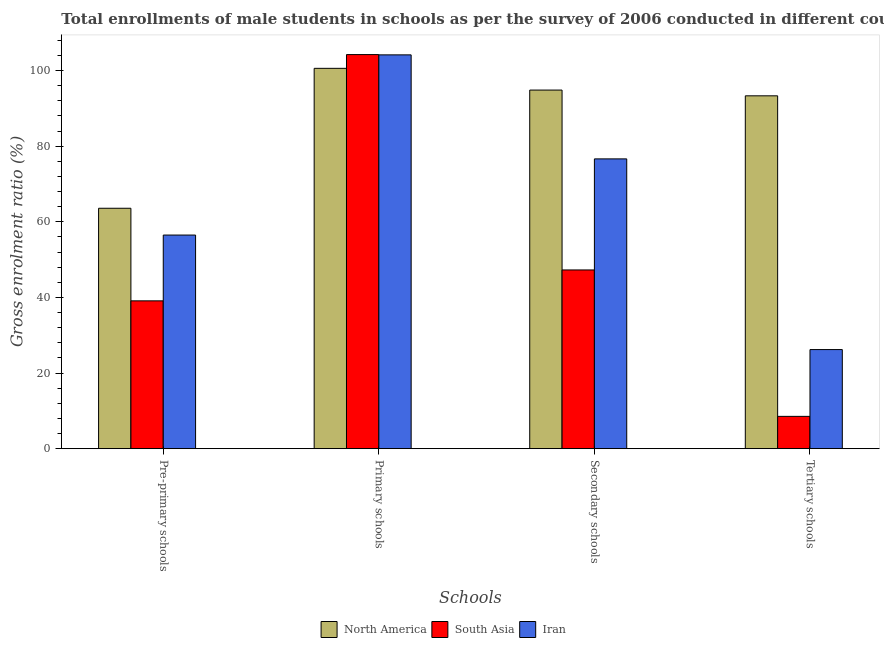How many different coloured bars are there?
Give a very brief answer. 3. How many bars are there on the 4th tick from the left?
Your answer should be compact. 3. How many bars are there on the 3rd tick from the right?
Keep it short and to the point. 3. What is the label of the 1st group of bars from the left?
Provide a short and direct response. Pre-primary schools. What is the gross enrolment ratio(male) in primary schools in Iran?
Offer a very short reply. 104.14. Across all countries, what is the maximum gross enrolment ratio(male) in pre-primary schools?
Make the answer very short. 63.58. Across all countries, what is the minimum gross enrolment ratio(male) in tertiary schools?
Offer a very short reply. 8.55. What is the total gross enrolment ratio(male) in tertiary schools in the graph?
Keep it short and to the point. 128.07. What is the difference between the gross enrolment ratio(male) in primary schools in South Asia and that in North America?
Make the answer very short. 3.64. What is the difference between the gross enrolment ratio(male) in primary schools in South Asia and the gross enrolment ratio(male) in tertiary schools in North America?
Give a very brief answer. 10.91. What is the average gross enrolment ratio(male) in secondary schools per country?
Ensure brevity in your answer.  72.91. What is the difference between the gross enrolment ratio(male) in secondary schools and gross enrolment ratio(male) in primary schools in North America?
Keep it short and to the point. -5.75. In how many countries, is the gross enrolment ratio(male) in primary schools greater than 44 %?
Make the answer very short. 3. What is the ratio of the gross enrolment ratio(male) in tertiary schools in Iran to that in North America?
Offer a terse response. 0.28. Is the difference between the gross enrolment ratio(male) in tertiary schools in Iran and North America greater than the difference between the gross enrolment ratio(male) in secondary schools in Iran and North America?
Keep it short and to the point. No. What is the difference between the highest and the second highest gross enrolment ratio(male) in secondary schools?
Give a very brief answer. 18.2. What is the difference between the highest and the lowest gross enrolment ratio(male) in tertiary schools?
Provide a short and direct response. 84.77. In how many countries, is the gross enrolment ratio(male) in pre-primary schools greater than the average gross enrolment ratio(male) in pre-primary schools taken over all countries?
Provide a short and direct response. 2. Is it the case that in every country, the sum of the gross enrolment ratio(male) in tertiary schools and gross enrolment ratio(male) in secondary schools is greater than the sum of gross enrolment ratio(male) in pre-primary schools and gross enrolment ratio(male) in primary schools?
Offer a very short reply. No. What does the 1st bar from the right in Secondary schools represents?
Ensure brevity in your answer.  Iran. Is it the case that in every country, the sum of the gross enrolment ratio(male) in pre-primary schools and gross enrolment ratio(male) in primary schools is greater than the gross enrolment ratio(male) in secondary schools?
Your answer should be very brief. Yes. How many bars are there?
Give a very brief answer. 12. Are all the bars in the graph horizontal?
Your answer should be very brief. No. Are the values on the major ticks of Y-axis written in scientific E-notation?
Give a very brief answer. No. Does the graph contain grids?
Provide a succinct answer. No. What is the title of the graph?
Provide a succinct answer. Total enrollments of male students in schools as per the survey of 2006 conducted in different countries. What is the label or title of the X-axis?
Ensure brevity in your answer.  Schools. What is the label or title of the Y-axis?
Provide a succinct answer. Gross enrolment ratio (%). What is the Gross enrolment ratio (%) in North America in Pre-primary schools?
Your response must be concise. 63.58. What is the Gross enrolment ratio (%) of South Asia in Pre-primary schools?
Offer a very short reply. 39.09. What is the Gross enrolment ratio (%) of Iran in Pre-primary schools?
Provide a short and direct response. 56.49. What is the Gross enrolment ratio (%) of North America in Primary schools?
Ensure brevity in your answer.  100.58. What is the Gross enrolment ratio (%) in South Asia in Primary schools?
Make the answer very short. 104.22. What is the Gross enrolment ratio (%) in Iran in Primary schools?
Offer a very short reply. 104.14. What is the Gross enrolment ratio (%) in North America in Secondary schools?
Provide a short and direct response. 94.84. What is the Gross enrolment ratio (%) in South Asia in Secondary schools?
Offer a terse response. 47.26. What is the Gross enrolment ratio (%) of Iran in Secondary schools?
Offer a terse response. 76.64. What is the Gross enrolment ratio (%) of North America in Tertiary schools?
Ensure brevity in your answer.  93.31. What is the Gross enrolment ratio (%) in South Asia in Tertiary schools?
Your answer should be very brief. 8.55. What is the Gross enrolment ratio (%) of Iran in Tertiary schools?
Your answer should be compact. 26.21. Across all Schools, what is the maximum Gross enrolment ratio (%) in North America?
Offer a terse response. 100.58. Across all Schools, what is the maximum Gross enrolment ratio (%) in South Asia?
Your answer should be very brief. 104.22. Across all Schools, what is the maximum Gross enrolment ratio (%) of Iran?
Offer a very short reply. 104.14. Across all Schools, what is the minimum Gross enrolment ratio (%) in North America?
Your response must be concise. 63.58. Across all Schools, what is the minimum Gross enrolment ratio (%) in South Asia?
Your response must be concise. 8.55. Across all Schools, what is the minimum Gross enrolment ratio (%) of Iran?
Your answer should be compact. 26.21. What is the total Gross enrolment ratio (%) of North America in the graph?
Make the answer very short. 352.31. What is the total Gross enrolment ratio (%) in South Asia in the graph?
Provide a succinct answer. 199.12. What is the total Gross enrolment ratio (%) in Iran in the graph?
Give a very brief answer. 263.48. What is the difference between the Gross enrolment ratio (%) of North America in Pre-primary schools and that in Primary schools?
Ensure brevity in your answer.  -37. What is the difference between the Gross enrolment ratio (%) of South Asia in Pre-primary schools and that in Primary schools?
Your answer should be very brief. -65.13. What is the difference between the Gross enrolment ratio (%) in Iran in Pre-primary schools and that in Primary schools?
Offer a terse response. -47.65. What is the difference between the Gross enrolment ratio (%) of North America in Pre-primary schools and that in Secondary schools?
Ensure brevity in your answer.  -31.26. What is the difference between the Gross enrolment ratio (%) in South Asia in Pre-primary schools and that in Secondary schools?
Provide a short and direct response. -8.17. What is the difference between the Gross enrolment ratio (%) in Iran in Pre-primary schools and that in Secondary schools?
Offer a terse response. -20.14. What is the difference between the Gross enrolment ratio (%) in North America in Pre-primary schools and that in Tertiary schools?
Offer a terse response. -29.73. What is the difference between the Gross enrolment ratio (%) of South Asia in Pre-primary schools and that in Tertiary schools?
Your answer should be compact. 30.55. What is the difference between the Gross enrolment ratio (%) in Iran in Pre-primary schools and that in Tertiary schools?
Make the answer very short. 30.29. What is the difference between the Gross enrolment ratio (%) of North America in Primary schools and that in Secondary schools?
Provide a short and direct response. 5.75. What is the difference between the Gross enrolment ratio (%) in South Asia in Primary schools and that in Secondary schools?
Your answer should be compact. 56.96. What is the difference between the Gross enrolment ratio (%) in Iran in Primary schools and that in Secondary schools?
Provide a short and direct response. 27.51. What is the difference between the Gross enrolment ratio (%) of North America in Primary schools and that in Tertiary schools?
Your answer should be very brief. 7.27. What is the difference between the Gross enrolment ratio (%) of South Asia in Primary schools and that in Tertiary schools?
Make the answer very short. 95.68. What is the difference between the Gross enrolment ratio (%) in Iran in Primary schools and that in Tertiary schools?
Make the answer very short. 77.94. What is the difference between the Gross enrolment ratio (%) in North America in Secondary schools and that in Tertiary schools?
Provide a succinct answer. 1.52. What is the difference between the Gross enrolment ratio (%) of South Asia in Secondary schools and that in Tertiary schools?
Provide a short and direct response. 38.72. What is the difference between the Gross enrolment ratio (%) of Iran in Secondary schools and that in Tertiary schools?
Offer a very short reply. 50.43. What is the difference between the Gross enrolment ratio (%) of North America in Pre-primary schools and the Gross enrolment ratio (%) of South Asia in Primary schools?
Give a very brief answer. -40.64. What is the difference between the Gross enrolment ratio (%) of North America in Pre-primary schools and the Gross enrolment ratio (%) of Iran in Primary schools?
Provide a succinct answer. -40.56. What is the difference between the Gross enrolment ratio (%) in South Asia in Pre-primary schools and the Gross enrolment ratio (%) in Iran in Primary schools?
Your answer should be very brief. -65.05. What is the difference between the Gross enrolment ratio (%) in North America in Pre-primary schools and the Gross enrolment ratio (%) in South Asia in Secondary schools?
Ensure brevity in your answer.  16.31. What is the difference between the Gross enrolment ratio (%) of North America in Pre-primary schools and the Gross enrolment ratio (%) of Iran in Secondary schools?
Your answer should be compact. -13.06. What is the difference between the Gross enrolment ratio (%) of South Asia in Pre-primary schools and the Gross enrolment ratio (%) of Iran in Secondary schools?
Keep it short and to the point. -37.54. What is the difference between the Gross enrolment ratio (%) of North America in Pre-primary schools and the Gross enrolment ratio (%) of South Asia in Tertiary schools?
Give a very brief answer. 55.03. What is the difference between the Gross enrolment ratio (%) of North America in Pre-primary schools and the Gross enrolment ratio (%) of Iran in Tertiary schools?
Give a very brief answer. 37.37. What is the difference between the Gross enrolment ratio (%) in South Asia in Pre-primary schools and the Gross enrolment ratio (%) in Iran in Tertiary schools?
Your response must be concise. 12.89. What is the difference between the Gross enrolment ratio (%) in North America in Primary schools and the Gross enrolment ratio (%) in South Asia in Secondary schools?
Offer a terse response. 53.32. What is the difference between the Gross enrolment ratio (%) in North America in Primary schools and the Gross enrolment ratio (%) in Iran in Secondary schools?
Provide a succinct answer. 23.95. What is the difference between the Gross enrolment ratio (%) of South Asia in Primary schools and the Gross enrolment ratio (%) of Iran in Secondary schools?
Your response must be concise. 27.58. What is the difference between the Gross enrolment ratio (%) of North America in Primary schools and the Gross enrolment ratio (%) of South Asia in Tertiary schools?
Your response must be concise. 92.04. What is the difference between the Gross enrolment ratio (%) in North America in Primary schools and the Gross enrolment ratio (%) in Iran in Tertiary schools?
Keep it short and to the point. 74.38. What is the difference between the Gross enrolment ratio (%) of South Asia in Primary schools and the Gross enrolment ratio (%) of Iran in Tertiary schools?
Your response must be concise. 78.01. What is the difference between the Gross enrolment ratio (%) in North America in Secondary schools and the Gross enrolment ratio (%) in South Asia in Tertiary schools?
Provide a short and direct response. 86.29. What is the difference between the Gross enrolment ratio (%) of North America in Secondary schools and the Gross enrolment ratio (%) of Iran in Tertiary schools?
Your answer should be very brief. 68.63. What is the difference between the Gross enrolment ratio (%) in South Asia in Secondary schools and the Gross enrolment ratio (%) in Iran in Tertiary schools?
Your response must be concise. 21.06. What is the average Gross enrolment ratio (%) of North America per Schools?
Your answer should be compact. 88.08. What is the average Gross enrolment ratio (%) in South Asia per Schools?
Give a very brief answer. 49.78. What is the average Gross enrolment ratio (%) in Iran per Schools?
Your response must be concise. 65.87. What is the difference between the Gross enrolment ratio (%) in North America and Gross enrolment ratio (%) in South Asia in Pre-primary schools?
Offer a very short reply. 24.49. What is the difference between the Gross enrolment ratio (%) of North America and Gross enrolment ratio (%) of Iran in Pre-primary schools?
Make the answer very short. 7.09. What is the difference between the Gross enrolment ratio (%) in South Asia and Gross enrolment ratio (%) in Iran in Pre-primary schools?
Give a very brief answer. -17.4. What is the difference between the Gross enrolment ratio (%) of North America and Gross enrolment ratio (%) of South Asia in Primary schools?
Give a very brief answer. -3.64. What is the difference between the Gross enrolment ratio (%) of North America and Gross enrolment ratio (%) of Iran in Primary schools?
Provide a short and direct response. -3.56. What is the difference between the Gross enrolment ratio (%) in South Asia and Gross enrolment ratio (%) in Iran in Primary schools?
Ensure brevity in your answer.  0.08. What is the difference between the Gross enrolment ratio (%) of North America and Gross enrolment ratio (%) of South Asia in Secondary schools?
Ensure brevity in your answer.  47.57. What is the difference between the Gross enrolment ratio (%) in North America and Gross enrolment ratio (%) in Iran in Secondary schools?
Your response must be concise. 18.2. What is the difference between the Gross enrolment ratio (%) of South Asia and Gross enrolment ratio (%) of Iran in Secondary schools?
Your response must be concise. -29.37. What is the difference between the Gross enrolment ratio (%) of North America and Gross enrolment ratio (%) of South Asia in Tertiary schools?
Your answer should be compact. 84.77. What is the difference between the Gross enrolment ratio (%) in North America and Gross enrolment ratio (%) in Iran in Tertiary schools?
Offer a terse response. 67.11. What is the difference between the Gross enrolment ratio (%) of South Asia and Gross enrolment ratio (%) of Iran in Tertiary schools?
Your answer should be compact. -17.66. What is the ratio of the Gross enrolment ratio (%) in North America in Pre-primary schools to that in Primary schools?
Offer a terse response. 0.63. What is the ratio of the Gross enrolment ratio (%) in South Asia in Pre-primary schools to that in Primary schools?
Offer a very short reply. 0.38. What is the ratio of the Gross enrolment ratio (%) in Iran in Pre-primary schools to that in Primary schools?
Keep it short and to the point. 0.54. What is the ratio of the Gross enrolment ratio (%) of North America in Pre-primary schools to that in Secondary schools?
Your answer should be very brief. 0.67. What is the ratio of the Gross enrolment ratio (%) in South Asia in Pre-primary schools to that in Secondary schools?
Provide a short and direct response. 0.83. What is the ratio of the Gross enrolment ratio (%) of Iran in Pre-primary schools to that in Secondary schools?
Make the answer very short. 0.74. What is the ratio of the Gross enrolment ratio (%) in North America in Pre-primary schools to that in Tertiary schools?
Provide a succinct answer. 0.68. What is the ratio of the Gross enrolment ratio (%) of South Asia in Pre-primary schools to that in Tertiary schools?
Give a very brief answer. 4.58. What is the ratio of the Gross enrolment ratio (%) of Iran in Pre-primary schools to that in Tertiary schools?
Offer a very short reply. 2.16. What is the ratio of the Gross enrolment ratio (%) in North America in Primary schools to that in Secondary schools?
Provide a short and direct response. 1.06. What is the ratio of the Gross enrolment ratio (%) in South Asia in Primary schools to that in Secondary schools?
Provide a succinct answer. 2.21. What is the ratio of the Gross enrolment ratio (%) in Iran in Primary schools to that in Secondary schools?
Provide a succinct answer. 1.36. What is the ratio of the Gross enrolment ratio (%) of North America in Primary schools to that in Tertiary schools?
Ensure brevity in your answer.  1.08. What is the ratio of the Gross enrolment ratio (%) in South Asia in Primary schools to that in Tertiary schools?
Your answer should be very brief. 12.2. What is the ratio of the Gross enrolment ratio (%) of Iran in Primary schools to that in Tertiary schools?
Ensure brevity in your answer.  3.97. What is the ratio of the Gross enrolment ratio (%) in North America in Secondary schools to that in Tertiary schools?
Make the answer very short. 1.02. What is the ratio of the Gross enrolment ratio (%) in South Asia in Secondary schools to that in Tertiary schools?
Provide a succinct answer. 5.53. What is the ratio of the Gross enrolment ratio (%) in Iran in Secondary schools to that in Tertiary schools?
Make the answer very short. 2.92. What is the difference between the highest and the second highest Gross enrolment ratio (%) of North America?
Ensure brevity in your answer.  5.75. What is the difference between the highest and the second highest Gross enrolment ratio (%) in South Asia?
Keep it short and to the point. 56.96. What is the difference between the highest and the second highest Gross enrolment ratio (%) in Iran?
Provide a succinct answer. 27.51. What is the difference between the highest and the lowest Gross enrolment ratio (%) in North America?
Give a very brief answer. 37. What is the difference between the highest and the lowest Gross enrolment ratio (%) of South Asia?
Provide a short and direct response. 95.68. What is the difference between the highest and the lowest Gross enrolment ratio (%) of Iran?
Your response must be concise. 77.94. 